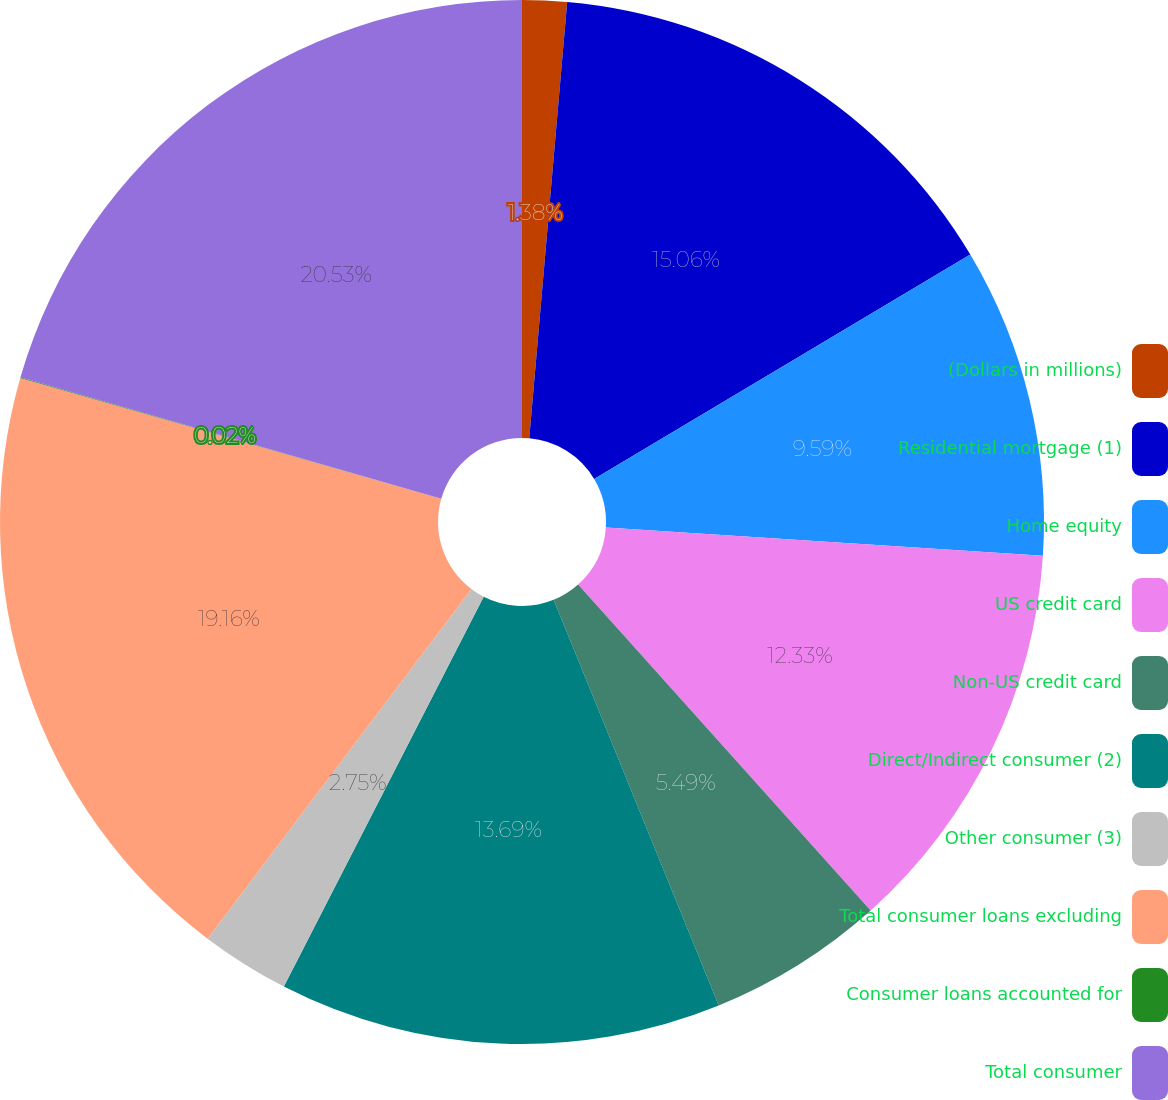<chart> <loc_0><loc_0><loc_500><loc_500><pie_chart><fcel>(Dollars in millions)<fcel>Residential mortgage (1)<fcel>Home equity<fcel>US credit card<fcel>Non-US credit card<fcel>Direct/Indirect consumer (2)<fcel>Other consumer (3)<fcel>Total consumer loans excluding<fcel>Consumer loans accounted for<fcel>Total consumer<nl><fcel>1.38%<fcel>15.06%<fcel>9.59%<fcel>12.33%<fcel>5.49%<fcel>13.69%<fcel>2.75%<fcel>19.16%<fcel>0.02%<fcel>20.53%<nl></chart> 